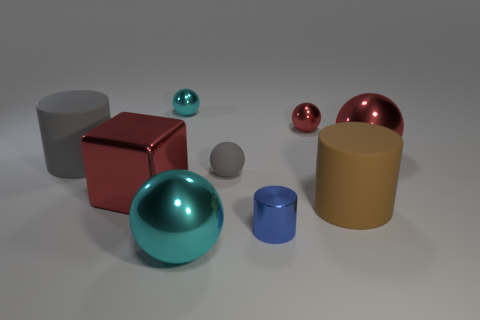Subtract all gray cylinders. How many cylinders are left? 2 Subtract all blocks. How many objects are left? 8 Subtract 3 spheres. How many spheres are left? 2 Subtract all gray balls. How many balls are left? 4 Subtract all small purple metallic things. Subtract all large cyan metal things. How many objects are left? 8 Add 6 big gray rubber cylinders. How many big gray rubber cylinders are left? 7 Add 3 small blue metal things. How many small blue metal things exist? 4 Add 1 metallic cylinders. How many objects exist? 10 Subtract 0 purple cylinders. How many objects are left? 9 Subtract all cyan blocks. Subtract all yellow cylinders. How many blocks are left? 1 